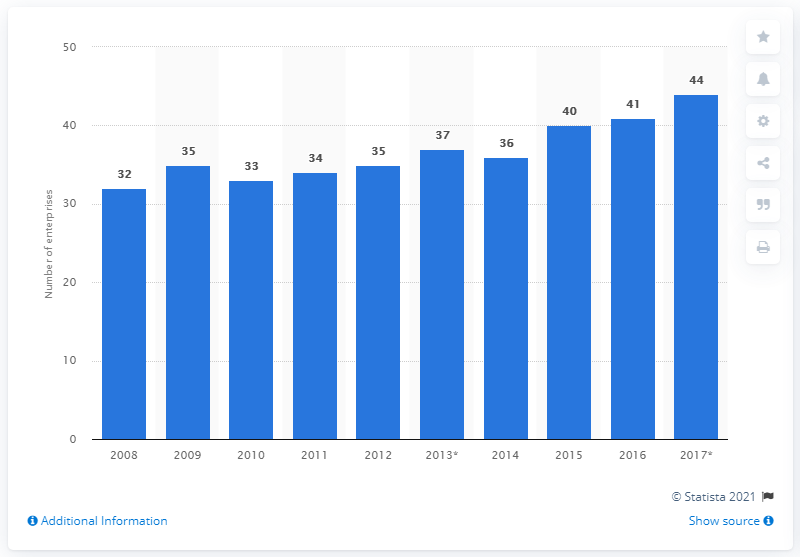Specify some key components in this picture. In 2017, there were 44 enterprises operating in the cocoa, chocolate, and sugar confectionery industry in Finland. 